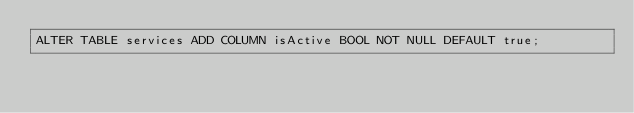Convert code to text. <code><loc_0><loc_0><loc_500><loc_500><_SQL_>ALTER TABLE services ADD COLUMN isActive BOOL NOT NULL DEFAULT true;</code> 